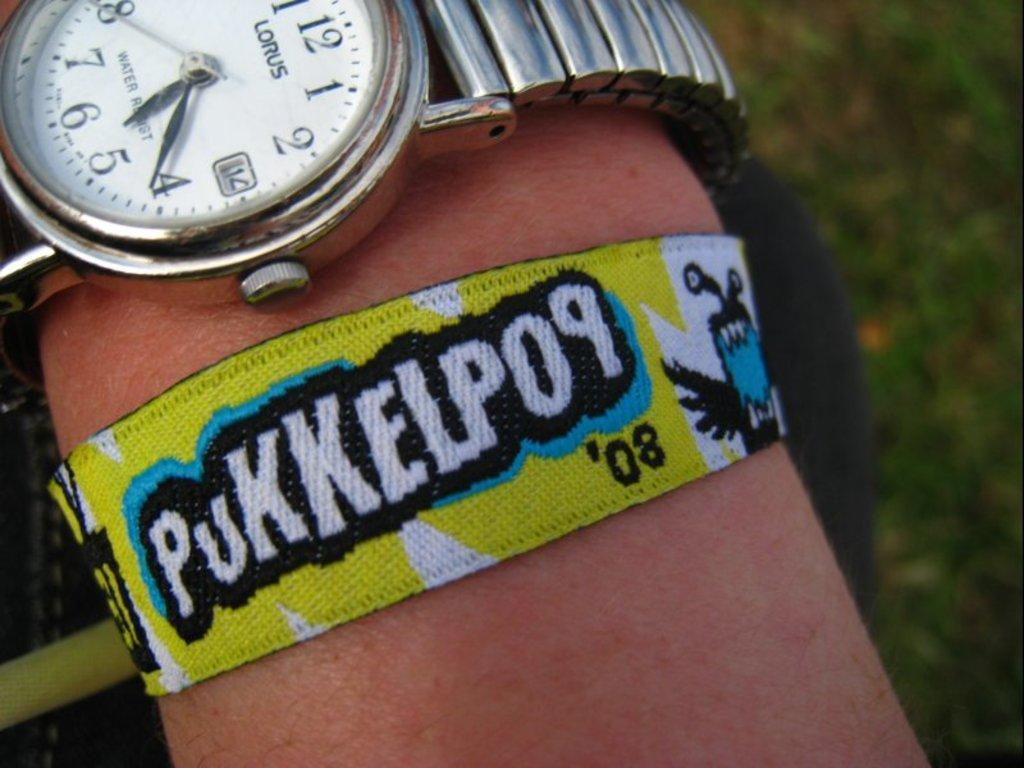<image>
Present a compact description of the photo's key features. A  yellow festival wristband that says Pukkelpop 08. 